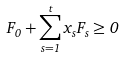Convert formula to latex. <formula><loc_0><loc_0><loc_500><loc_500>F _ { 0 } + \sum _ { s = 1 } ^ { t } x _ { s } F _ { s } \geq 0</formula> 